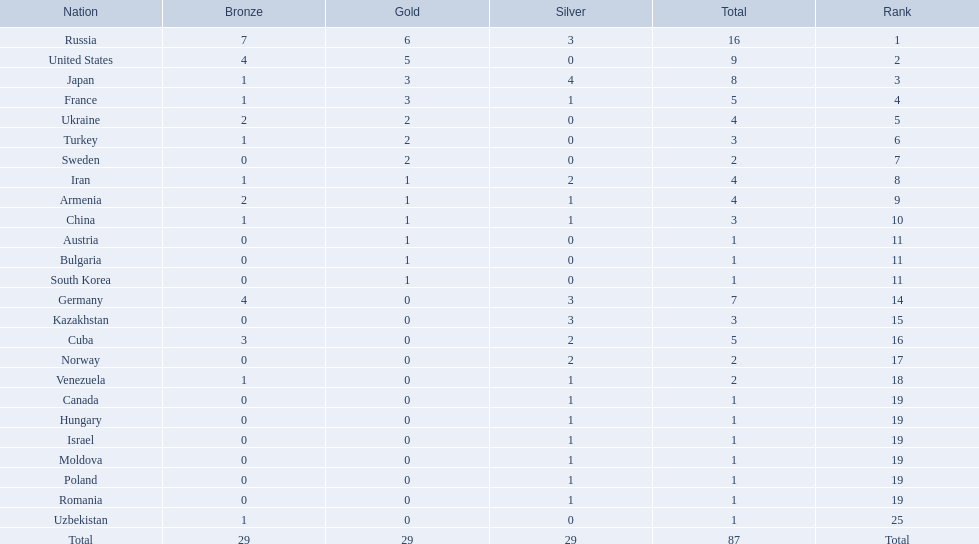What was iran's ranking? 8. What was germany's ranking? 14. Between iran and germany, which was not in the top 10? Germany. 